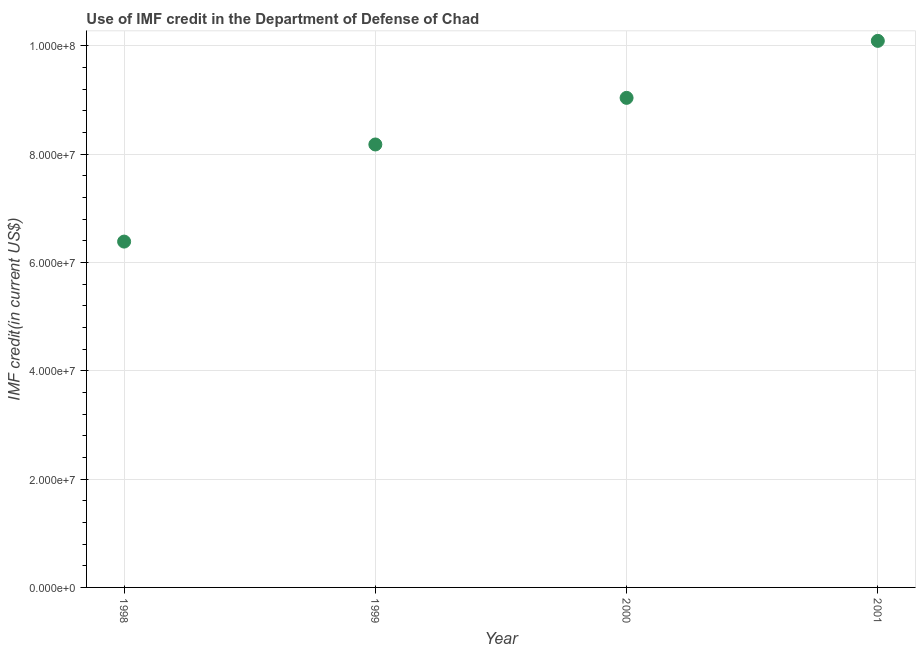What is the use of imf credit in dod in 2000?
Keep it short and to the point. 9.04e+07. Across all years, what is the maximum use of imf credit in dod?
Provide a succinct answer. 1.01e+08. Across all years, what is the minimum use of imf credit in dod?
Provide a short and direct response. 6.38e+07. What is the sum of the use of imf credit in dod?
Offer a very short reply. 3.37e+08. What is the difference between the use of imf credit in dod in 1999 and 2001?
Keep it short and to the point. -1.91e+07. What is the average use of imf credit in dod per year?
Provide a short and direct response. 8.42e+07. What is the median use of imf credit in dod?
Your answer should be compact. 8.61e+07. What is the ratio of the use of imf credit in dod in 1999 to that in 2000?
Your answer should be very brief. 0.9. Is the difference between the use of imf credit in dod in 1999 and 2001 greater than the difference between any two years?
Ensure brevity in your answer.  No. What is the difference between the highest and the second highest use of imf credit in dod?
Ensure brevity in your answer.  1.05e+07. What is the difference between the highest and the lowest use of imf credit in dod?
Make the answer very short. 3.71e+07. Does the use of imf credit in dod monotonically increase over the years?
Your answer should be very brief. Yes. How many dotlines are there?
Your answer should be very brief. 1. Are the values on the major ticks of Y-axis written in scientific E-notation?
Offer a very short reply. Yes. Does the graph contain any zero values?
Offer a terse response. No. What is the title of the graph?
Ensure brevity in your answer.  Use of IMF credit in the Department of Defense of Chad. What is the label or title of the X-axis?
Provide a short and direct response. Year. What is the label or title of the Y-axis?
Provide a succinct answer. IMF credit(in current US$). What is the IMF credit(in current US$) in 1998?
Make the answer very short. 6.38e+07. What is the IMF credit(in current US$) in 1999?
Ensure brevity in your answer.  8.18e+07. What is the IMF credit(in current US$) in 2000?
Keep it short and to the point. 9.04e+07. What is the IMF credit(in current US$) in 2001?
Your answer should be compact. 1.01e+08. What is the difference between the IMF credit(in current US$) in 1998 and 1999?
Ensure brevity in your answer.  -1.79e+07. What is the difference between the IMF credit(in current US$) in 1998 and 2000?
Offer a terse response. -2.65e+07. What is the difference between the IMF credit(in current US$) in 1998 and 2001?
Keep it short and to the point. -3.71e+07. What is the difference between the IMF credit(in current US$) in 1999 and 2000?
Your answer should be compact. -8.60e+06. What is the difference between the IMF credit(in current US$) in 1999 and 2001?
Ensure brevity in your answer.  -1.91e+07. What is the difference between the IMF credit(in current US$) in 2000 and 2001?
Provide a succinct answer. -1.05e+07. What is the ratio of the IMF credit(in current US$) in 1998 to that in 1999?
Offer a terse response. 0.78. What is the ratio of the IMF credit(in current US$) in 1998 to that in 2000?
Your answer should be compact. 0.71. What is the ratio of the IMF credit(in current US$) in 1998 to that in 2001?
Provide a succinct answer. 0.63. What is the ratio of the IMF credit(in current US$) in 1999 to that in 2000?
Provide a short and direct response. 0.91. What is the ratio of the IMF credit(in current US$) in 1999 to that in 2001?
Your response must be concise. 0.81. What is the ratio of the IMF credit(in current US$) in 2000 to that in 2001?
Offer a very short reply. 0.9. 